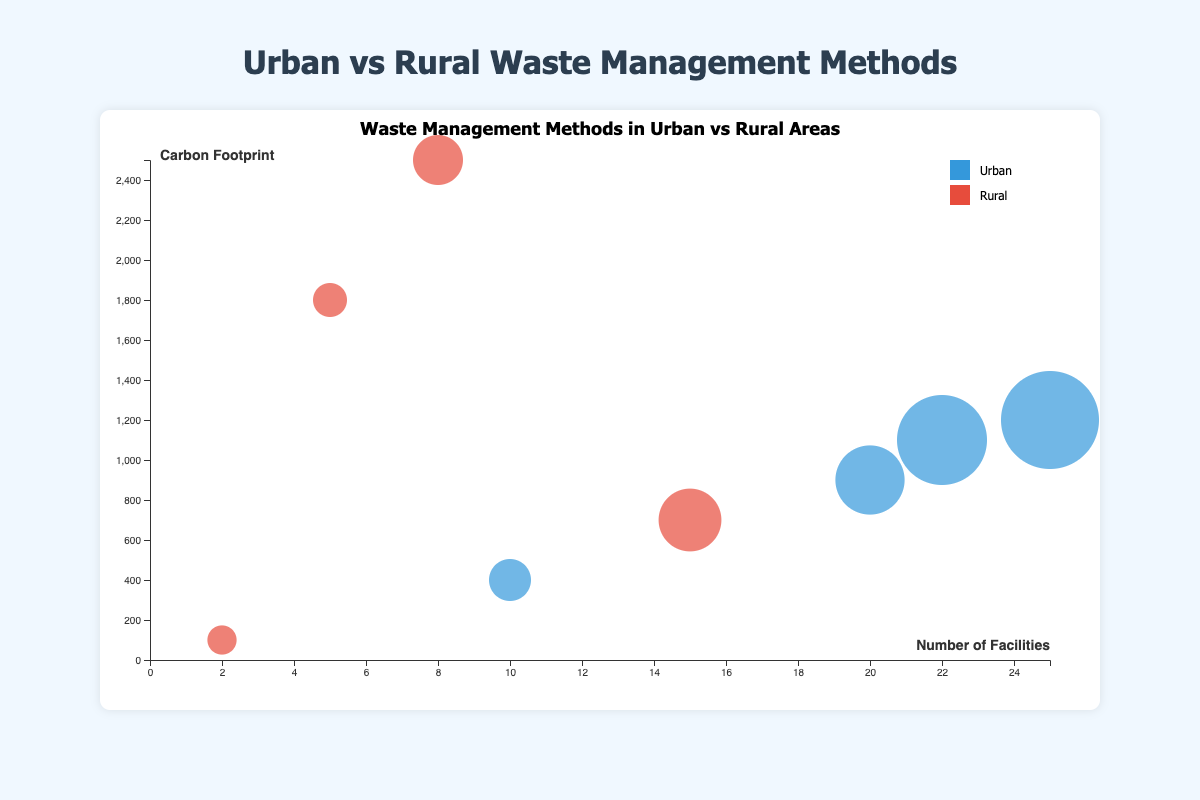Which location has the highest carbon footprint for managing organic waste? Look at the y-axis for carbon footprints and identify the bubble for organic waste among the urban and rural regions. The highest point on the y-axis will have the highest carbon footprint.
Answer: Rocky Mountains What is the total number of facilities handling plastic waste in urban areas? Sum the number of facilities dedicated to plastic waste management in the urban region of New York City and Los Angeles.
Answer: 47 Among rural regions, which method has the lowest carbon footprint for electronic waste management? Identify the bubbles for electronic waste in the rural region and compare their positions on the y-axis. The bubble lowest on the y-axis has the lowest carbon footprint.
Answer: Donation in Great Plains Which waste type in urban regions shows the largest bubble size, and what does it represent? Compare the sizes of the bubbles for plastic, organic, and electronic waste in urban regions. The largest bubble size corresponds to the highest volume of waste.
Answer: Plastic in New York City and Los Angeles represents the highest volume In rural regions, which waste management method for organic waste has more facilities, mulching or burning? Find and compare the bubbles denoting mulching and burning for organic waste in rural regions by their x-axis values, which represent the number of facilities.
Answer: Mulching What is the primary waste management method for plastic waste in urban areas? Identify the bubbles for plastic waste in urban regions and look at the waste management method label in the tooltip description.
Answer: Recycling How do the carbon footprints of electronic waste management compare between urban and rural areas? Find the bubbles for electronic waste in both urban and rural regions and compare their positions on the y-axis. The urban bubble is for Chicago, and the rural bubble is for Great Plains.
Answer: Higher in Rural (Appalachia: 1800 vs. Chicago: 400) Which location manages the least volume of waste and what is the type of waste? Identify the smallest bubble in the entire figure and look at the tooltip for the waste type and volume.
Answer: Great Plains with Electronic waste Based on the bubble sizes, does rural or urban area have higher plastic waste volume on average? Visualize and estimate the average size of the bubbles corresponding to plastic waste in rural and urban areas by comparing New York City, Los Angeles (urban) vs. Appalachia (rural).
Answer: Urban 